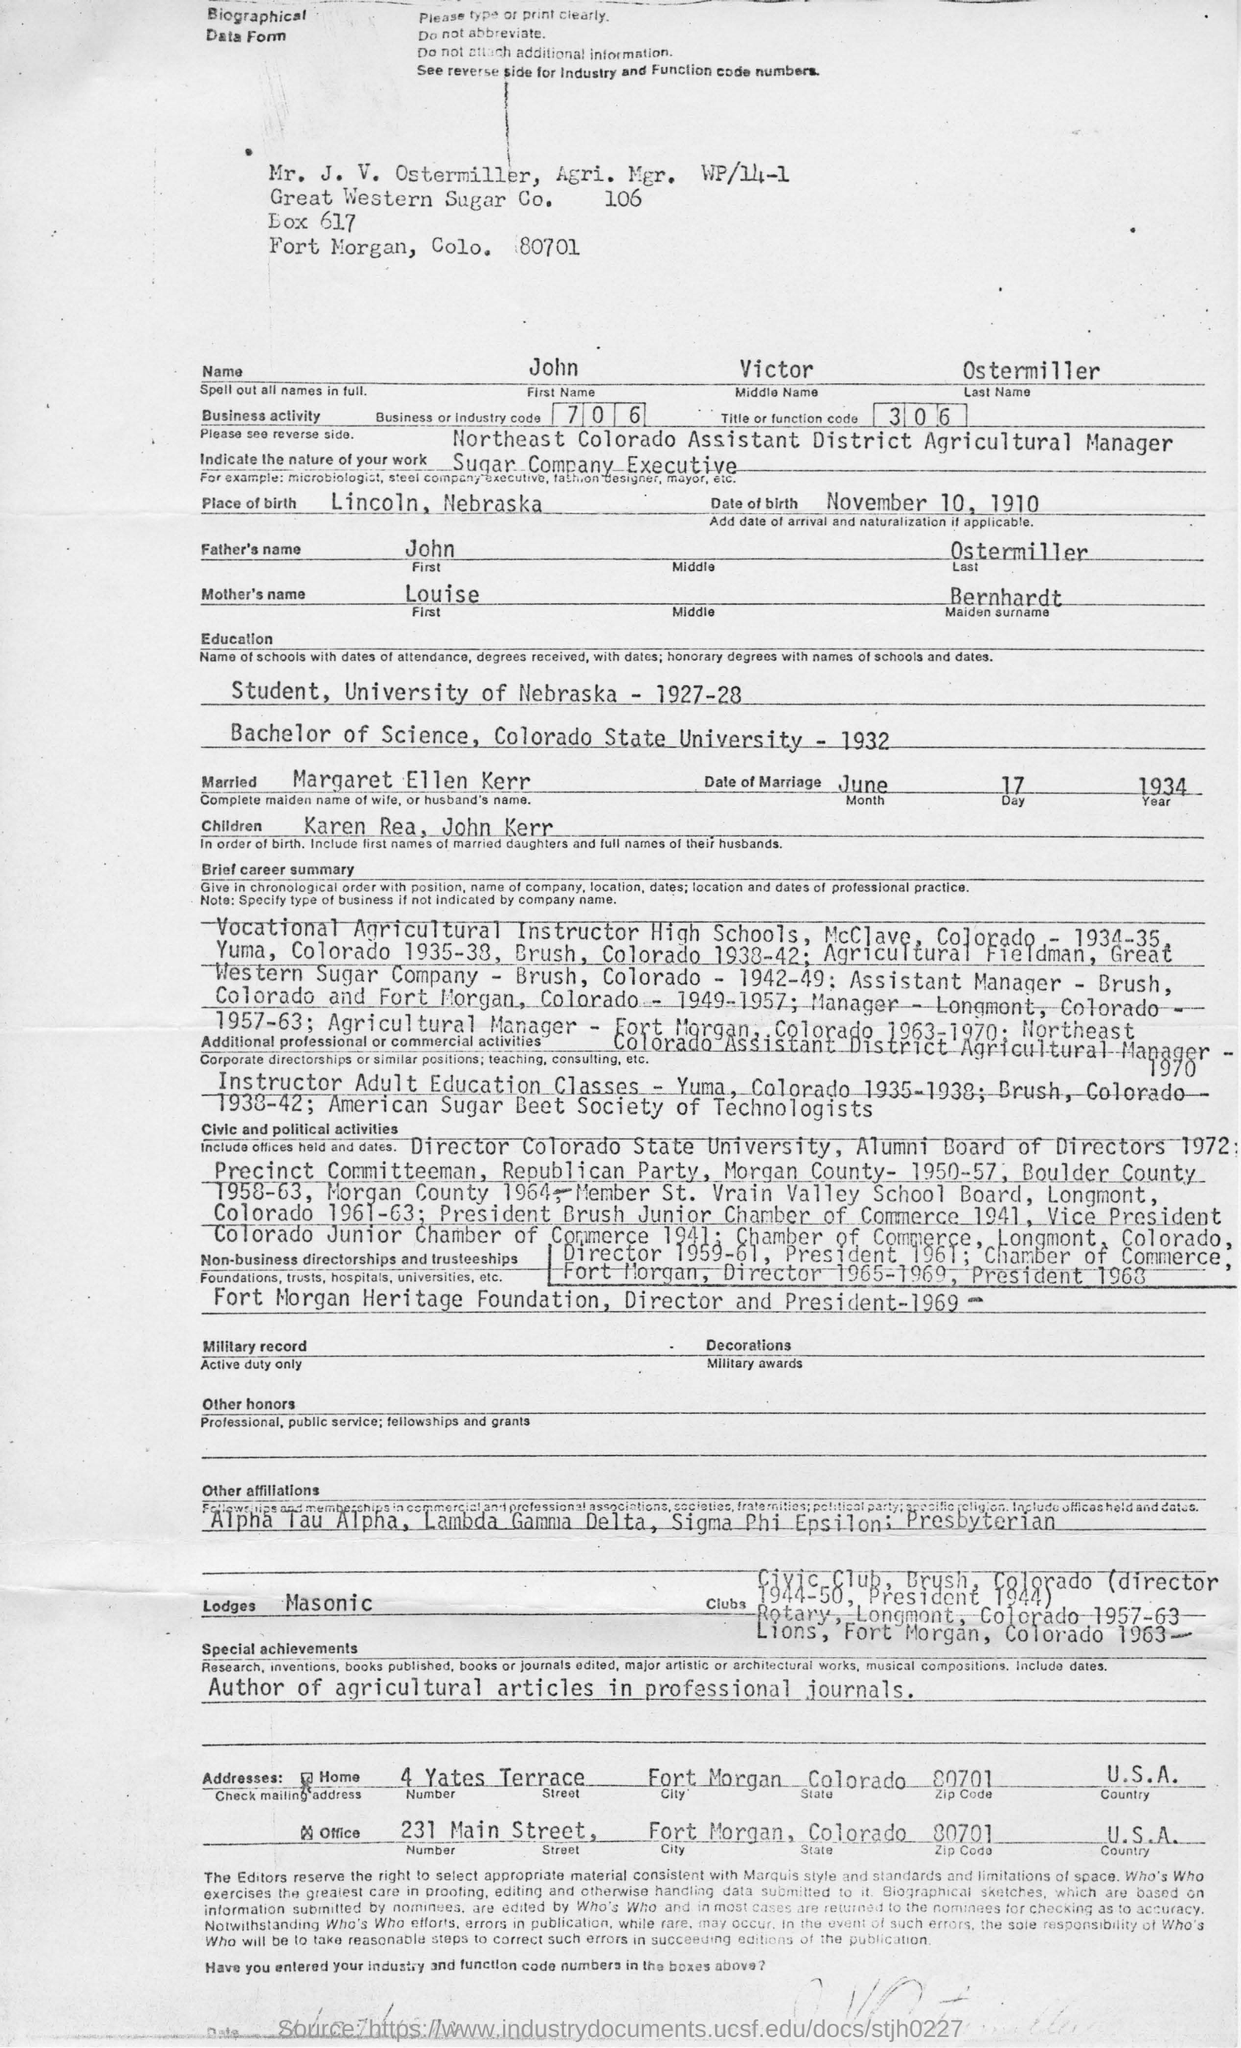What is the name of the person given in the form?
Offer a very short reply. John Victor Ostermiller. What is the business or industry code?
Your answer should be compact. 706. What is John Victor Ostermiller's nature of work?
Your answer should be compact. Sugar Company Executive. Where did John get his Bachelor of Science from?
Offer a very short reply. Colorado State University. What did John author?
Provide a succinct answer. Agricultural articles in professional journals. Who is John married to?
Your answer should be compact. Margaret Ellen Kerr. Which lodge is John affiliated to?
Your response must be concise. Masonic. 